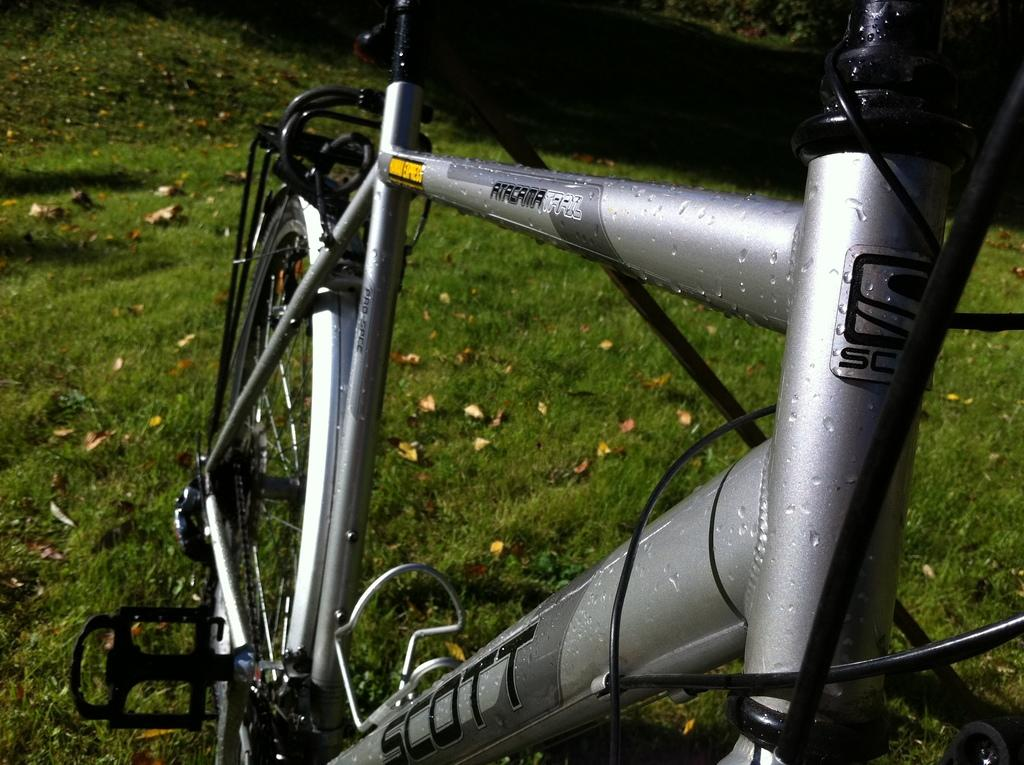What color is the bicycle in the image? The bicycle in the image is grey. Where is the bicycle located? The bicycle is on grassy land. What can be found on the grassy land besides the bicycle? There are dry leaves on the grassy land. What type of cord is being used to tie the cat to the bicycle in the image? There is no cat or cord present in the image; it only features a grey color bicycle on grassy land with dry leaves. 